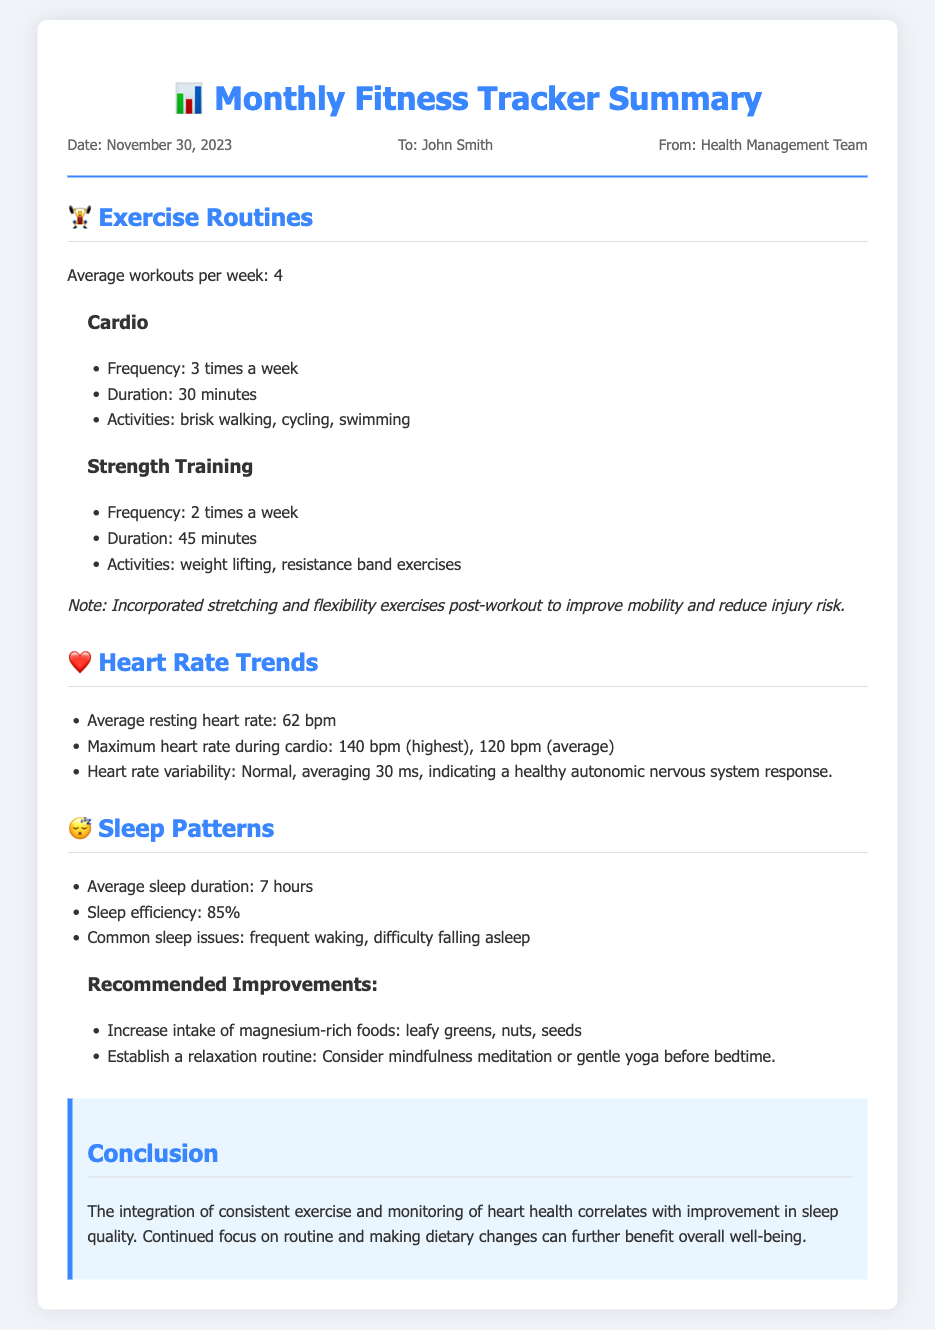What is the average workouts per week? The average workouts per week is mentioned in the exercise section of the document.
Answer: 4 What are the activities included in cardio? The activities related to cardio are listed under the cardio subsection in the exercise section.
Answer: brisk walking, cycling, swimming What is the maximum heart rate during cardio? The maximum heart rate during cardio is provided in the heart rate trends section.
Answer: 140 bpm What is the average sleep duration? The average sleep duration is specified in the sleep patterns section of the document.
Answer: 7 hours What type of foods are recommended to improve sleep? The document states specific food types in the recommended improvements subsection under sleep patterns.
Answer: magnesium-rich foods What is the average resting heart rate? The average resting heart rate is mentioned in the heart rate trends section.
Answer: 62 bpm How many times a week is strength training performed? The frequency of strength training is included in the exercise section of the document.
Answer: 2 times a week What is the sleep efficiency percentage? The percentage of sleep efficiency is indicated in the sleep patterns section.
Answer: 85% 